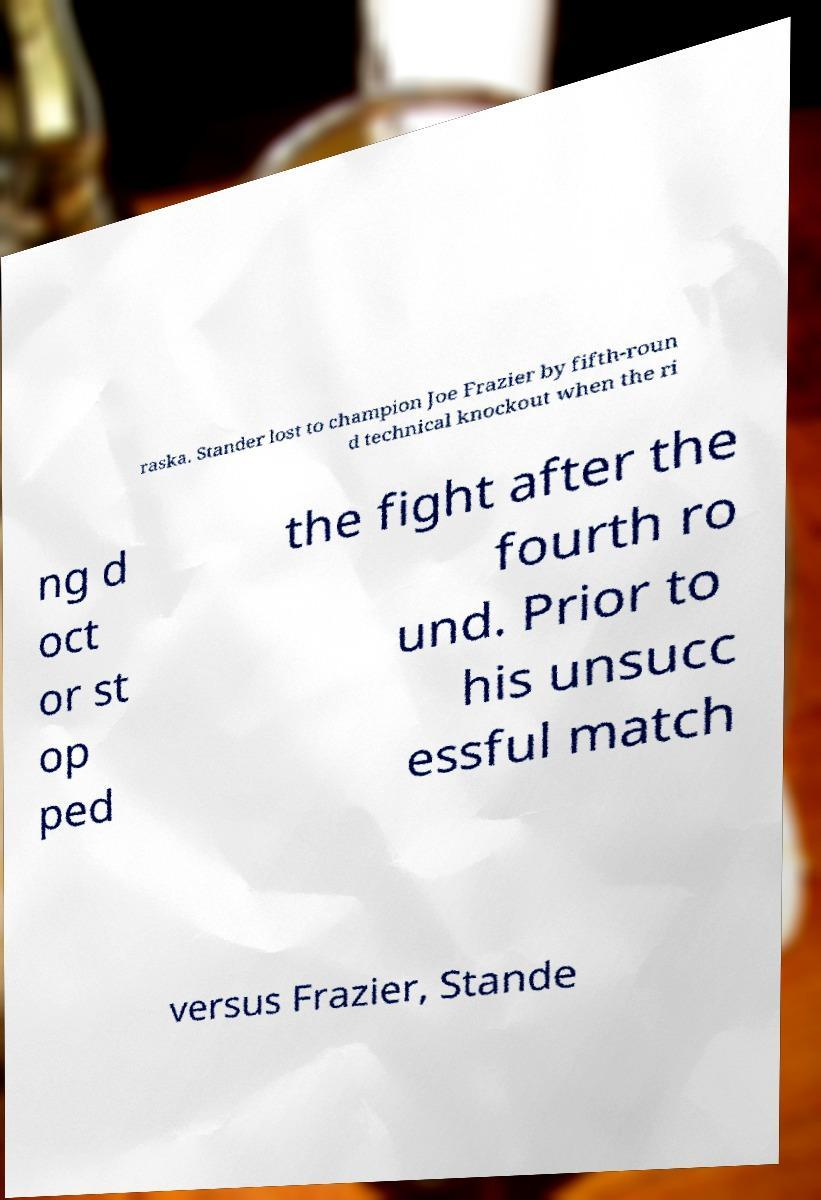Please read and relay the text visible in this image. What does it say? raska. Stander lost to champion Joe Frazier by fifth-roun d technical knockout when the ri ng d oct or st op ped the fight after the fourth ro und. Prior to his unsucc essful match versus Frazier, Stande 